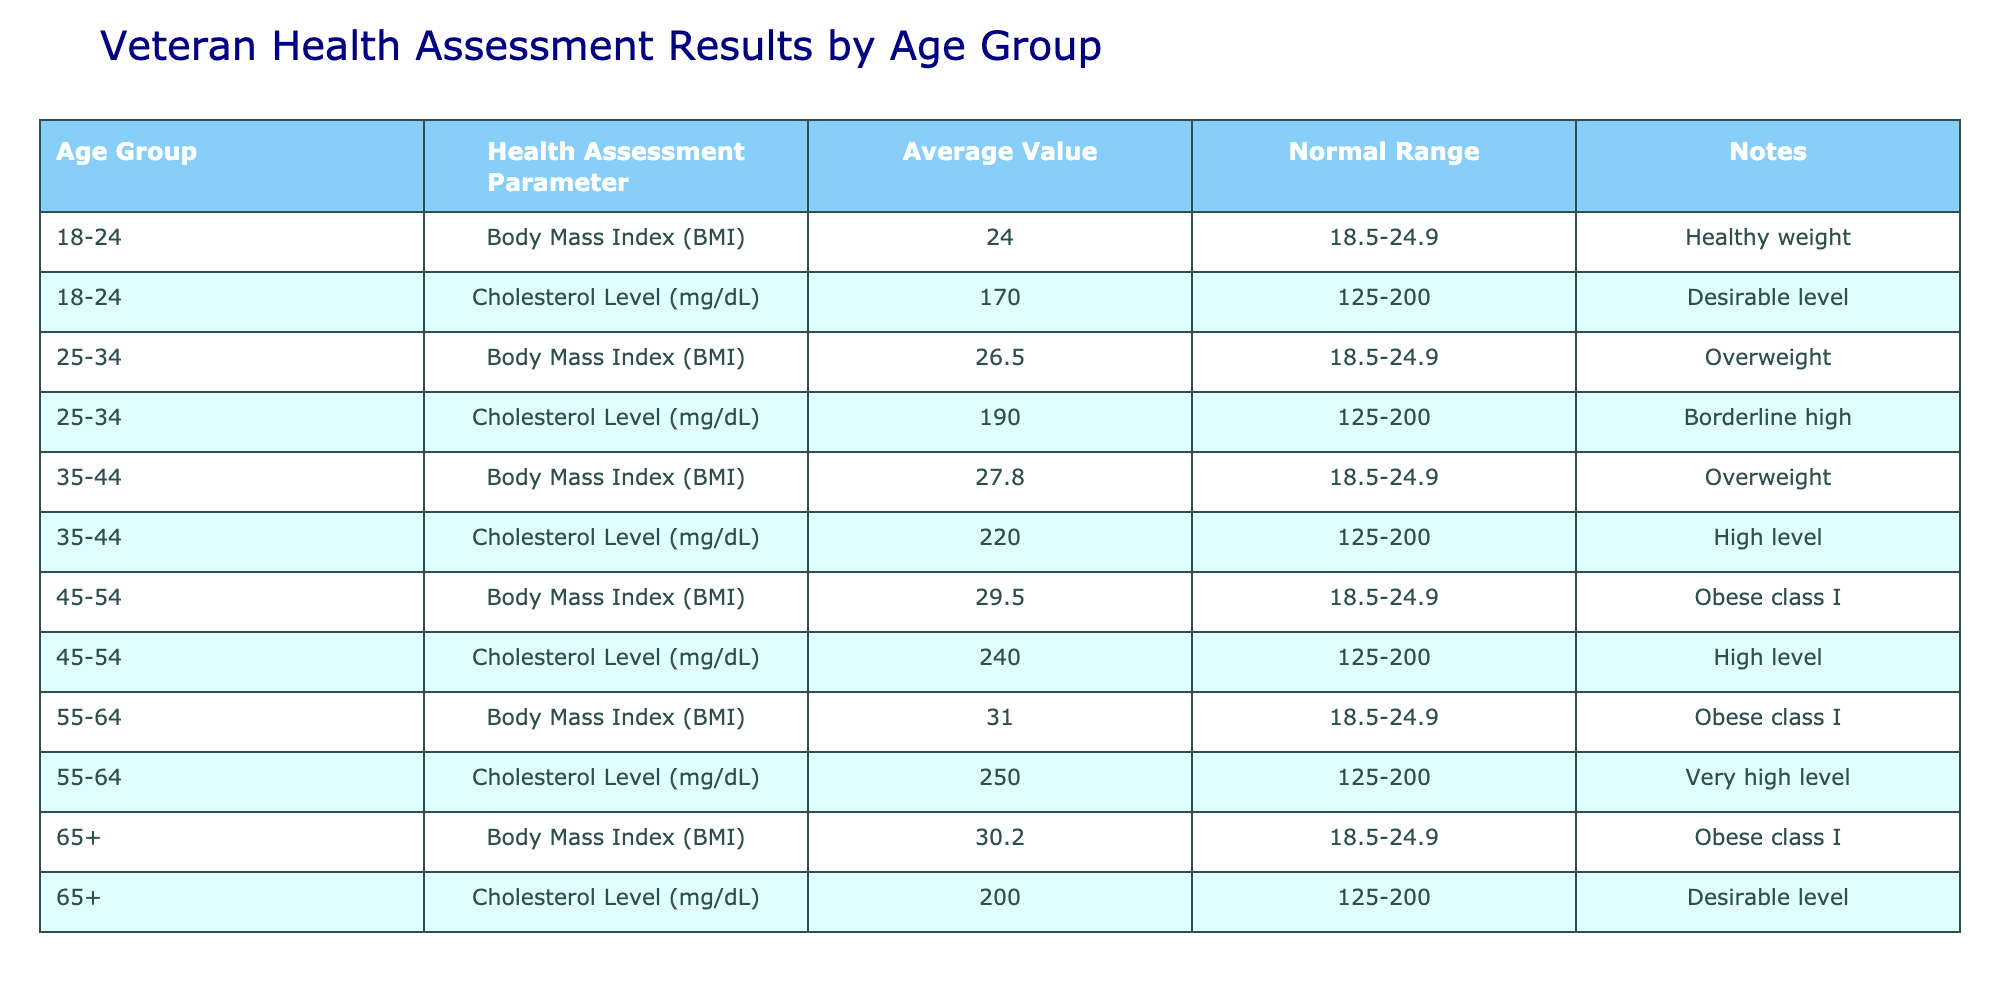What is the average Body Mass Index (BMI) for the age group 35-44? In the table, the average BMI for the age group 35-44 is listed as 27.8. This specific value can be found directly in the row corresponding to this age group.
Answer: 27.8 What is the cholesterol level average for the age group 55-64? The average cholesterol level for the age group 55-64 is provided in the table as 250 mg/dL, which can be directly retrieved from the relevant row.
Answer: 250 mg/dL Are there any age groups where the average BMI is classified as "Obese class I"? The age groups 45-54, 55-64, and 65+ have average BMIs of 29.5, 31.0, and 30.2, respectively, which are all classified as "Obese class I." This information can be confirmed by checking the corresponding notes in the table.
Answer: Yes What is the difference in average cholesterol levels between the age groups 25-34 and 35-44? The average cholesterol for the age group 25-34 is 190 mg/dL, while for 35-44, it is 220 mg/dL. The difference is calculated as 220 - 190 = 30 mg/dL, which can be determined by performing a subtraction on the two values.
Answer: 30 mg/dL Which age group has the highest average cholesterol level, and what is that value? The 55-64 age group has the highest average cholesterol level, which is 250 mg/dL. This can be identified in the table by comparing cholesterol values across all age groups.
Answer: 250 mg/dL What percentage of the age groups listed have an average cholesterol level in the normal range? In the table, the age groups 18-24 and 65+ have cholesterol levels of 170 mg/dL and 200 mg/dL, respectively, which fall within the normal range (125-200 mg/dL). There are 6 age groups listed, so the percentage is calculated as (2/6) * 100 = 33.3%.
Answer: 33.3% Is the average BMI for the age group 18-24 within the normal range? The average BMI for the age group 18-24 is 24.0, and the normal range for BMI is 18.5-24.9. Since 24.0 falls within this range, the answer is confirmed by checking the respective values in the table.
Answer: Yes What is the average Body Mass Index (BMI) across all age groups? The average BMI values are as follows: 24.0 (18-24), 26.5 (25-34), 27.8 (35-44), 29.5 (45-54), 31.0 (55-64), and 30.2 (65+). Summing these gives 24.0 + 26.5 + 27.8 + 29.5 + 31.0 + 30.2 = 169.0. To find the average, divide by 6, resulting in 169.0 / 6 = 28.17.
Answer: 28.17 